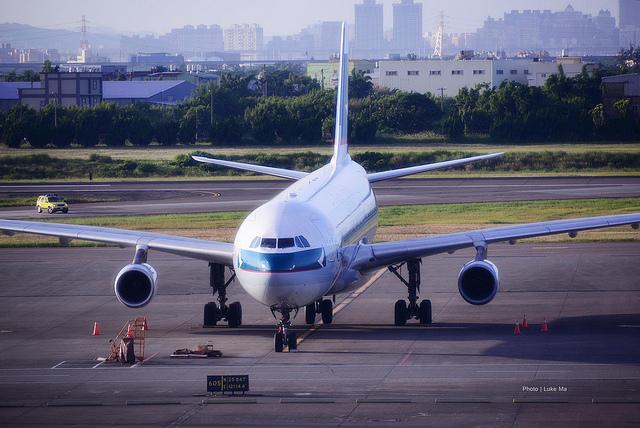Where is the plane at?
Quick response, please. Airport. What type of vehicle is in the background?
Keep it brief. Car. Is the plane flying?
Quick response, please. No. 